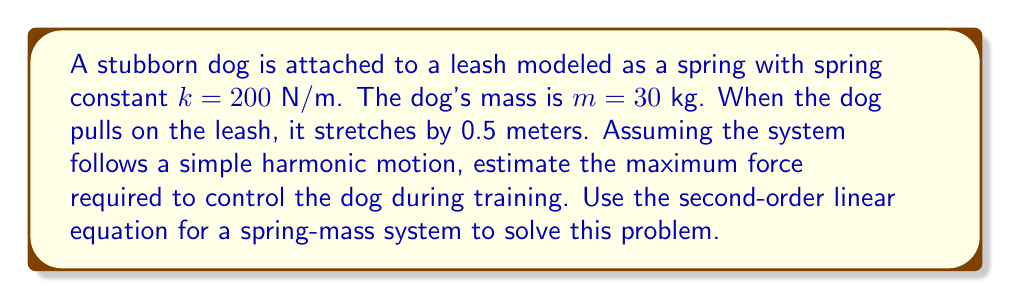Can you answer this question? To solve this problem, we'll use the second-order linear equation for a spring-mass system:

$$m\frac{d^2x}{dt^2} + kx = 0$$

Where:
- $m$ is the mass of the dog
- $k$ is the spring constant of the leash
- $x$ is the displacement from equilibrium

1. First, we need to find the amplitude of the motion. The amplitude is the maximum displacement, which is given as 0.5 meters.

2. The general solution to the spring-mass system equation is:

   $$x(t) = A\cos(\omega t + \phi)$$

   Where $A$ is the amplitude and $\omega$ is the angular frequency.

3. The angular frequency $\omega$ is given by:

   $$\omega = \sqrt{\frac{k}{m}} = \sqrt{\frac{200}{30}} \approx 2.58 \text{ rad/s}$$

4. The maximum force occurs when the displacement is at its maximum (i.e., at the amplitude). According to Hooke's Law:

   $$F = kx$$

   Where $F$ is the force, $k$ is the spring constant, and $x$ is the displacement.

5. Substituting the values:

   $$F = 200 \text{ N/m} \cdot 0.5 \text{ m} = 100 \text{ N}$$

Therefore, the maximum force required to control the dog during training is approximately 100 N.
Answer: The maximum force required to control the dog during training is approximately 100 N. 